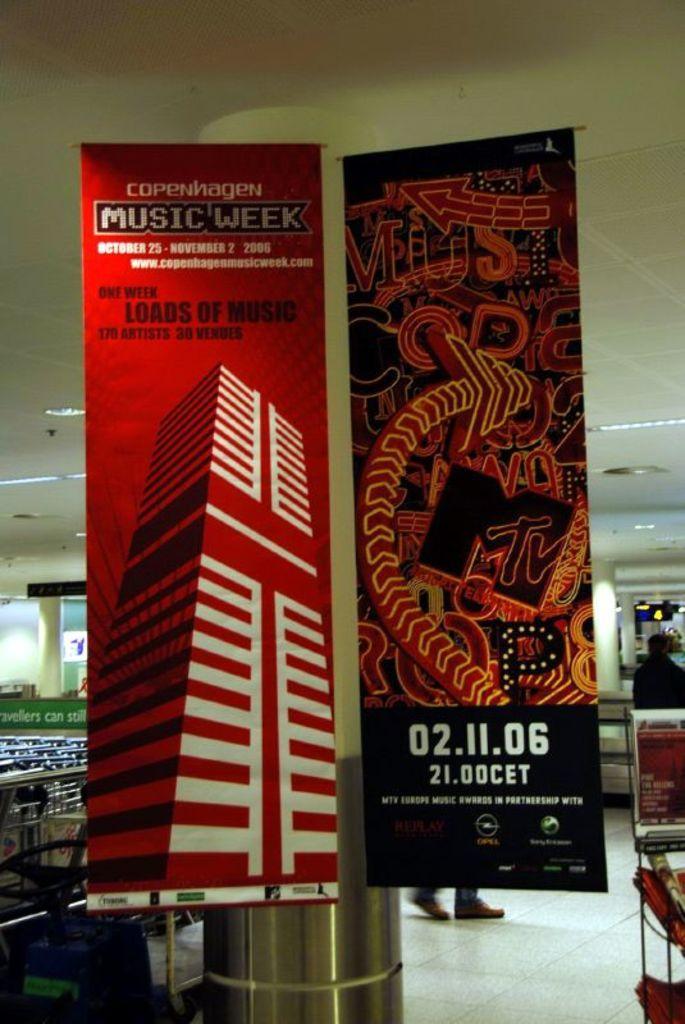Can you describe this image briefly? In this picture we can see banners near to the pillar. On the left we can see chairs and tables. On the right there is a person standing near to the table. Here we can see lights. 